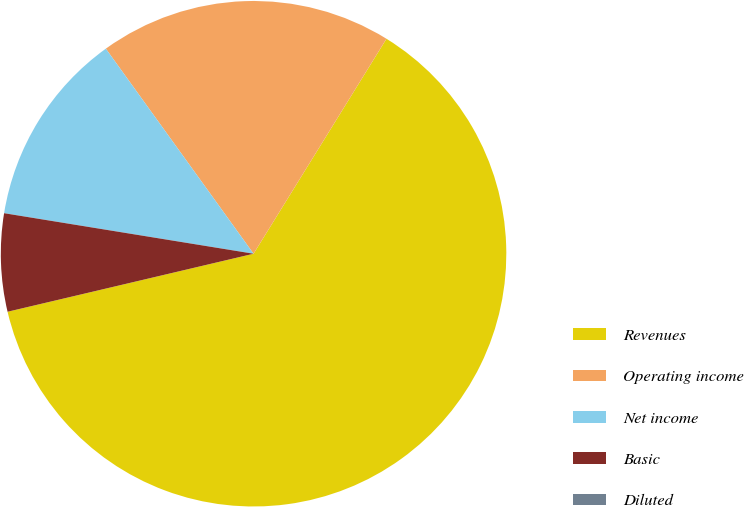Convert chart to OTSL. <chart><loc_0><loc_0><loc_500><loc_500><pie_chart><fcel>Revenues<fcel>Operating income<fcel>Net income<fcel>Basic<fcel>Diluted<nl><fcel>62.5%<fcel>18.75%<fcel>12.5%<fcel>6.25%<fcel>0.0%<nl></chart> 